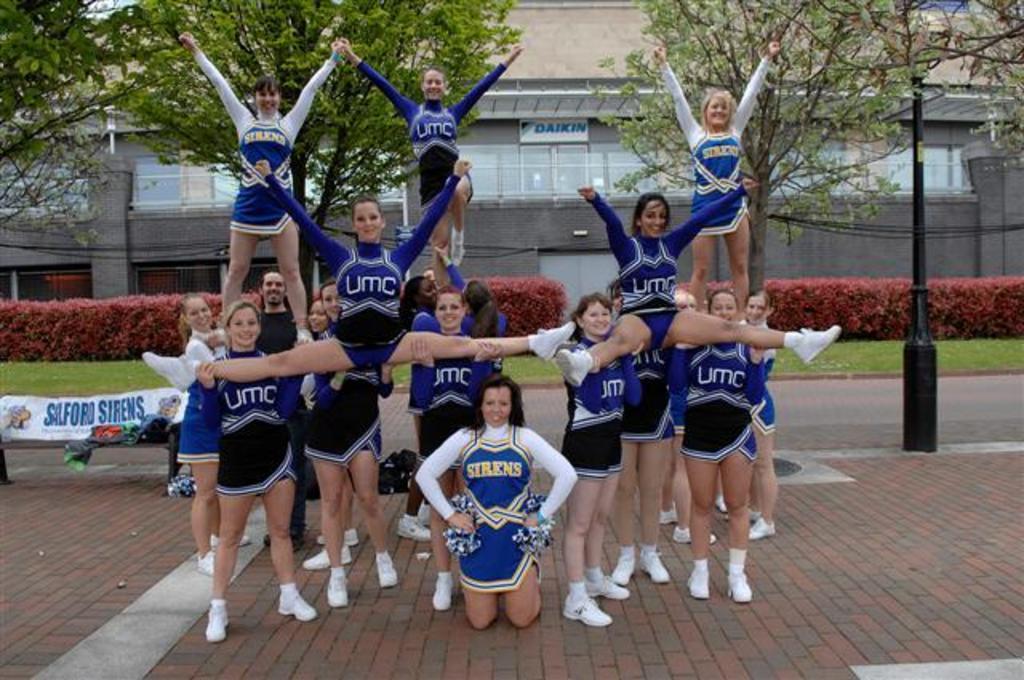What is the name of the team for the girl in the middle?
Provide a short and direct response. Sirens. 